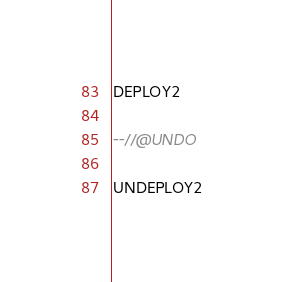<code> <loc_0><loc_0><loc_500><loc_500><_SQL_>DEPLOY2

--//@UNDO

UNDEPLOY2
</code> 